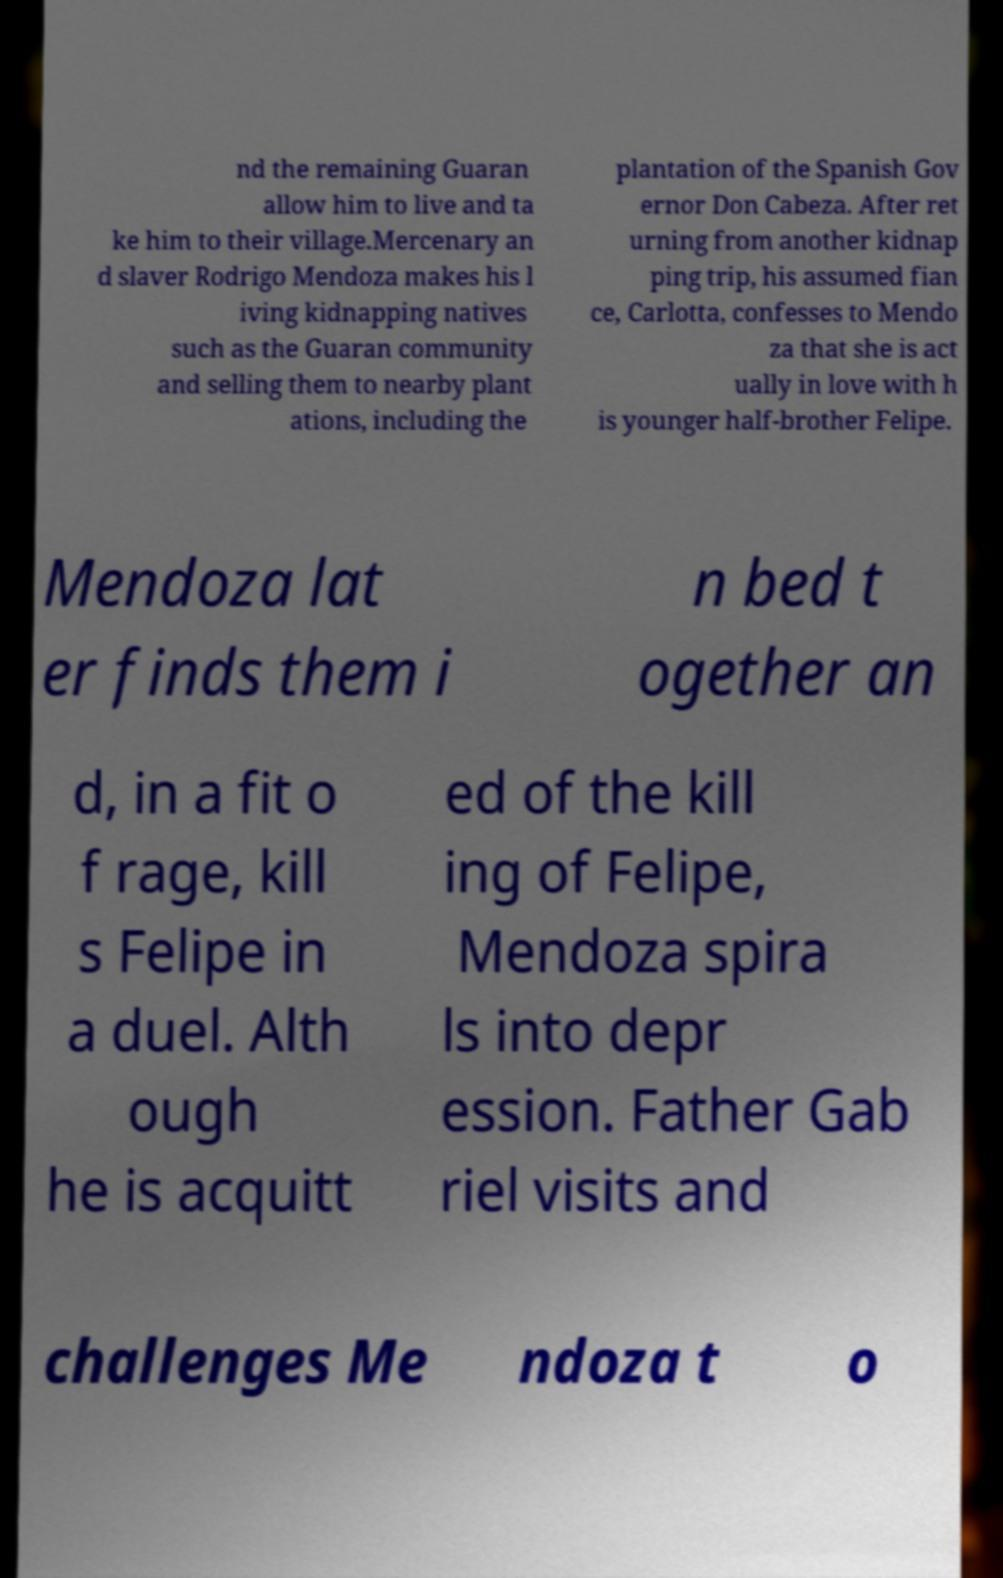Please read and relay the text visible in this image. What does it say? nd the remaining Guaran allow him to live and ta ke him to their village.Mercenary an d slaver Rodrigo Mendoza makes his l iving kidnapping natives such as the Guaran community and selling them to nearby plant ations, including the plantation of the Spanish Gov ernor Don Cabeza. After ret urning from another kidnap ping trip, his assumed fian ce, Carlotta, confesses to Mendo za that she is act ually in love with h is younger half-brother Felipe. Mendoza lat er finds them i n bed t ogether an d, in a fit o f rage, kill s Felipe in a duel. Alth ough he is acquitt ed of the kill ing of Felipe, Mendoza spira ls into depr ession. Father Gab riel visits and challenges Me ndoza t o 